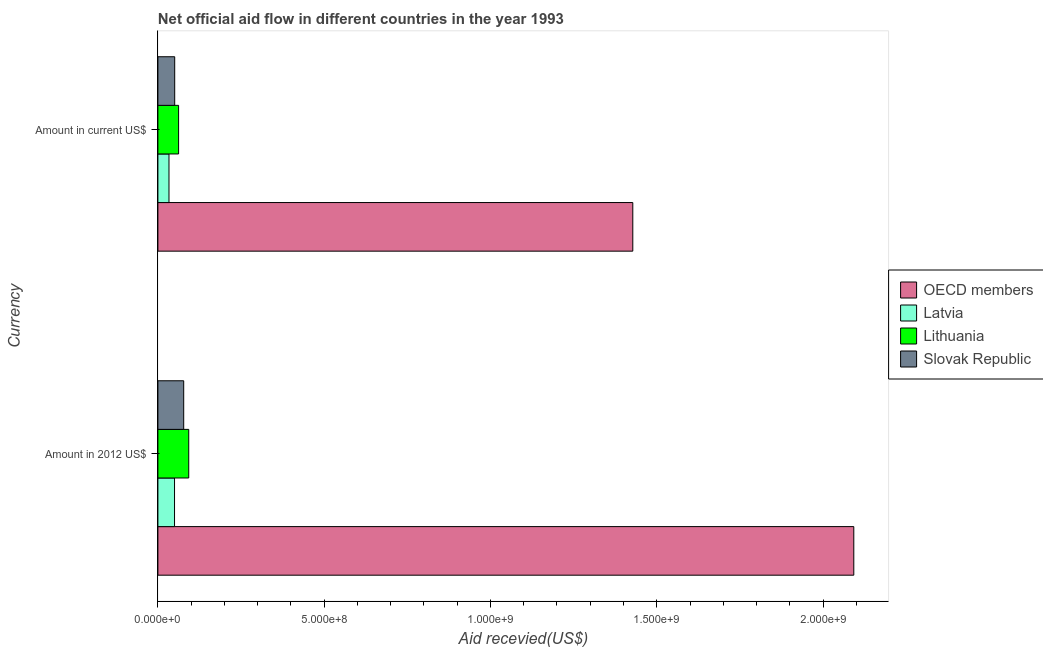How many different coloured bars are there?
Keep it short and to the point. 4. Are the number of bars per tick equal to the number of legend labels?
Offer a terse response. Yes. Are the number of bars on each tick of the Y-axis equal?
Offer a very short reply. Yes. How many bars are there on the 1st tick from the bottom?
Your answer should be very brief. 4. What is the label of the 2nd group of bars from the top?
Give a very brief answer. Amount in 2012 US$. What is the amount of aid received(expressed in us$) in OECD members?
Your answer should be very brief. 1.43e+09. Across all countries, what is the maximum amount of aid received(expressed in us$)?
Give a very brief answer. 1.43e+09. Across all countries, what is the minimum amount of aid received(expressed in 2012 us$)?
Offer a terse response. 5.00e+07. In which country was the amount of aid received(expressed in us$) maximum?
Ensure brevity in your answer.  OECD members. In which country was the amount of aid received(expressed in us$) minimum?
Offer a terse response. Latvia. What is the total amount of aid received(expressed in 2012 us$) in the graph?
Provide a short and direct response. 2.31e+09. What is the difference between the amount of aid received(expressed in 2012 us$) in Latvia and that in OECD members?
Give a very brief answer. -2.04e+09. What is the difference between the amount of aid received(expressed in 2012 us$) in OECD members and the amount of aid received(expressed in us$) in Slovak Republic?
Offer a terse response. 2.04e+09. What is the average amount of aid received(expressed in 2012 us$) per country?
Your answer should be compact. 5.78e+08. What is the difference between the amount of aid received(expressed in us$) and amount of aid received(expressed in 2012 us$) in Lithuania?
Your answer should be very brief. -3.05e+07. In how many countries, is the amount of aid received(expressed in us$) greater than 700000000 US$?
Make the answer very short. 1. What is the ratio of the amount of aid received(expressed in 2012 us$) in OECD members to that in Latvia?
Provide a short and direct response. 41.87. In how many countries, is the amount of aid received(expressed in 2012 us$) greater than the average amount of aid received(expressed in 2012 us$) taken over all countries?
Your answer should be very brief. 1. What does the 2nd bar from the top in Amount in 2012 US$ represents?
Ensure brevity in your answer.  Lithuania. What does the 1st bar from the bottom in Amount in current US$ represents?
Your response must be concise. OECD members. How many bars are there?
Your answer should be compact. 8. Are all the bars in the graph horizontal?
Ensure brevity in your answer.  Yes. How many countries are there in the graph?
Your response must be concise. 4. What is the difference between two consecutive major ticks on the X-axis?
Offer a very short reply. 5.00e+08. Are the values on the major ticks of X-axis written in scientific E-notation?
Offer a terse response. Yes. Does the graph contain grids?
Your response must be concise. No. How many legend labels are there?
Make the answer very short. 4. What is the title of the graph?
Your answer should be very brief. Net official aid flow in different countries in the year 1993. Does "Indonesia" appear as one of the legend labels in the graph?
Your answer should be very brief. No. What is the label or title of the X-axis?
Offer a terse response. Aid recevied(US$). What is the label or title of the Y-axis?
Provide a succinct answer. Currency. What is the Aid recevied(US$) of OECD members in Amount in 2012 US$?
Offer a very short reply. 2.09e+09. What is the Aid recevied(US$) of Latvia in Amount in 2012 US$?
Ensure brevity in your answer.  5.00e+07. What is the Aid recevied(US$) in Lithuania in Amount in 2012 US$?
Make the answer very short. 9.27e+07. What is the Aid recevied(US$) of Slovak Republic in Amount in 2012 US$?
Offer a terse response. 7.76e+07. What is the Aid recevied(US$) of OECD members in Amount in current US$?
Give a very brief answer. 1.43e+09. What is the Aid recevied(US$) of Latvia in Amount in current US$?
Provide a succinct answer. 3.33e+07. What is the Aid recevied(US$) in Lithuania in Amount in current US$?
Your answer should be very brief. 6.22e+07. What is the Aid recevied(US$) of Slovak Republic in Amount in current US$?
Provide a short and direct response. 5.05e+07. Across all Currency, what is the maximum Aid recevied(US$) in OECD members?
Provide a succinct answer. 2.09e+09. Across all Currency, what is the maximum Aid recevied(US$) of Latvia?
Give a very brief answer. 5.00e+07. Across all Currency, what is the maximum Aid recevied(US$) in Lithuania?
Ensure brevity in your answer.  9.27e+07. Across all Currency, what is the maximum Aid recevied(US$) of Slovak Republic?
Give a very brief answer. 7.76e+07. Across all Currency, what is the minimum Aid recevied(US$) in OECD members?
Provide a short and direct response. 1.43e+09. Across all Currency, what is the minimum Aid recevied(US$) in Latvia?
Ensure brevity in your answer.  3.33e+07. Across all Currency, what is the minimum Aid recevied(US$) in Lithuania?
Ensure brevity in your answer.  6.22e+07. Across all Currency, what is the minimum Aid recevied(US$) of Slovak Republic?
Your answer should be compact. 5.05e+07. What is the total Aid recevied(US$) of OECD members in the graph?
Keep it short and to the point. 3.52e+09. What is the total Aid recevied(US$) in Latvia in the graph?
Provide a short and direct response. 8.33e+07. What is the total Aid recevied(US$) of Lithuania in the graph?
Ensure brevity in your answer.  1.55e+08. What is the total Aid recevied(US$) of Slovak Republic in the graph?
Make the answer very short. 1.28e+08. What is the difference between the Aid recevied(US$) in OECD members in Amount in 2012 US$ and that in Amount in current US$?
Ensure brevity in your answer.  6.65e+08. What is the difference between the Aid recevied(US$) of Latvia in Amount in 2012 US$ and that in Amount in current US$?
Offer a very short reply. 1.67e+07. What is the difference between the Aid recevied(US$) in Lithuania in Amount in 2012 US$ and that in Amount in current US$?
Your response must be concise. 3.05e+07. What is the difference between the Aid recevied(US$) of Slovak Republic in Amount in 2012 US$ and that in Amount in current US$?
Your answer should be compact. 2.70e+07. What is the difference between the Aid recevied(US$) in OECD members in Amount in 2012 US$ and the Aid recevied(US$) in Latvia in Amount in current US$?
Your answer should be compact. 2.06e+09. What is the difference between the Aid recevied(US$) in OECD members in Amount in 2012 US$ and the Aid recevied(US$) in Lithuania in Amount in current US$?
Keep it short and to the point. 2.03e+09. What is the difference between the Aid recevied(US$) in OECD members in Amount in 2012 US$ and the Aid recevied(US$) in Slovak Republic in Amount in current US$?
Make the answer very short. 2.04e+09. What is the difference between the Aid recevied(US$) of Latvia in Amount in 2012 US$ and the Aid recevied(US$) of Lithuania in Amount in current US$?
Provide a short and direct response. -1.22e+07. What is the difference between the Aid recevied(US$) in Latvia in Amount in 2012 US$ and the Aid recevied(US$) in Slovak Republic in Amount in current US$?
Provide a short and direct response. -5.50e+05. What is the difference between the Aid recevied(US$) of Lithuania in Amount in 2012 US$ and the Aid recevied(US$) of Slovak Republic in Amount in current US$?
Your response must be concise. 4.22e+07. What is the average Aid recevied(US$) in OECD members per Currency?
Ensure brevity in your answer.  1.76e+09. What is the average Aid recevied(US$) in Latvia per Currency?
Make the answer very short. 4.16e+07. What is the average Aid recevied(US$) in Lithuania per Currency?
Your response must be concise. 7.74e+07. What is the average Aid recevied(US$) in Slovak Republic per Currency?
Keep it short and to the point. 6.40e+07. What is the difference between the Aid recevied(US$) in OECD members and Aid recevied(US$) in Latvia in Amount in 2012 US$?
Ensure brevity in your answer.  2.04e+09. What is the difference between the Aid recevied(US$) in OECD members and Aid recevied(US$) in Lithuania in Amount in 2012 US$?
Your answer should be compact. 2.00e+09. What is the difference between the Aid recevied(US$) in OECD members and Aid recevied(US$) in Slovak Republic in Amount in 2012 US$?
Make the answer very short. 2.01e+09. What is the difference between the Aid recevied(US$) in Latvia and Aid recevied(US$) in Lithuania in Amount in 2012 US$?
Your answer should be very brief. -4.27e+07. What is the difference between the Aid recevied(US$) in Latvia and Aid recevied(US$) in Slovak Republic in Amount in 2012 US$?
Your answer should be very brief. -2.76e+07. What is the difference between the Aid recevied(US$) of Lithuania and Aid recevied(US$) of Slovak Republic in Amount in 2012 US$?
Your answer should be compact. 1.51e+07. What is the difference between the Aid recevied(US$) of OECD members and Aid recevied(US$) of Latvia in Amount in current US$?
Your response must be concise. 1.39e+09. What is the difference between the Aid recevied(US$) in OECD members and Aid recevied(US$) in Lithuania in Amount in current US$?
Provide a succinct answer. 1.37e+09. What is the difference between the Aid recevied(US$) in OECD members and Aid recevied(US$) in Slovak Republic in Amount in current US$?
Keep it short and to the point. 1.38e+09. What is the difference between the Aid recevied(US$) in Latvia and Aid recevied(US$) in Lithuania in Amount in current US$?
Make the answer very short. -2.89e+07. What is the difference between the Aid recevied(US$) of Latvia and Aid recevied(US$) of Slovak Republic in Amount in current US$?
Provide a succinct answer. -1.72e+07. What is the difference between the Aid recevied(US$) in Lithuania and Aid recevied(US$) in Slovak Republic in Amount in current US$?
Give a very brief answer. 1.17e+07. What is the ratio of the Aid recevied(US$) in OECD members in Amount in 2012 US$ to that in Amount in current US$?
Give a very brief answer. 1.47. What is the ratio of the Aid recevied(US$) in Latvia in Amount in 2012 US$ to that in Amount in current US$?
Ensure brevity in your answer.  1.5. What is the ratio of the Aid recevied(US$) in Lithuania in Amount in 2012 US$ to that in Amount in current US$?
Your answer should be compact. 1.49. What is the ratio of the Aid recevied(US$) of Slovak Republic in Amount in 2012 US$ to that in Amount in current US$?
Your answer should be very brief. 1.54. What is the difference between the highest and the second highest Aid recevied(US$) in OECD members?
Keep it short and to the point. 6.65e+08. What is the difference between the highest and the second highest Aid recevied(US$) of Latvia?
Offer a very short reply. 1.67e+07. What is the difference between the highest and the second highest Aid recevied(US$) in Lithuania?
Give a very brief answer. 3.05e+07. What is the difference between the highest and the second highest Aid recevied(US$) of Slovak Republic?
Make the answer very short. 2.70e+07. What is the difference between the highest and the lowest Aid recevied(US$) in OECD members?
Keep it short and to the point. 6.65e+08. What is the difference between the highest and the lowest Aid recevied(US$) of Latvia?
Your response must be concise. 1.67e+07. What is the difference between the highest and the lowest Aid recevied(US$) of Lithuania?
Provide a succinct answer. 3.05e+07. What is the difference between the highest and the lowest Aid recevied(US$) of Slovak Republic?
Offer a very short reply. 2.70e+07. 